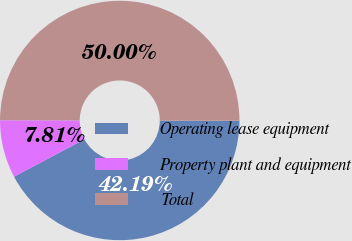Convert chart to OTSL. <chart><loc_0><loc_0><loc_500><loc_500><pie_chart><fcel>Operating lease equipment<fcel>Property plant and equipment<fcel>Total<nl><fcel>42.19%<fcel>7.81%<fcel>50.0%<nl></chart> 